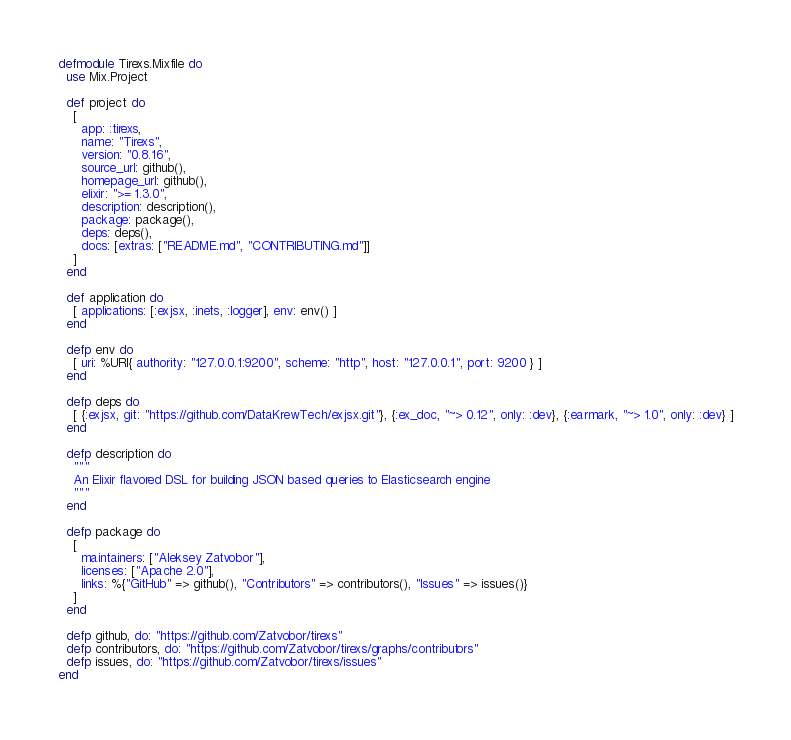Convert code to text. <code><loc_0><loc_0><loc_500><loc_500><_Elixir_>defmodule Tirexs.Mixfile do
  use Mix.Project

  def project do
    [
      app: :tirexs,
      name: "Tirexs",
      version: "0.8.16",
      source_url: github(),
      homepage_url: github(),
      elixir: ">= 1.3.0",
      description: description(),
      package: package(),
      deps: deps(),
      docs: [extras: ["README.md", "CONTRIBUTING.md"]]
    ]
  end

  def application do
    [ applications: [:exjsx, :inets, :logger], env: env() ]
  end

  defp env do
    [ uri: %URI{ authority: "127.0.0.1:9200", scheme: "http", host: "127.0.0.1", port: 9200 } ]
  end

  defp deps do
    [ {:exjsx, git: "https://github.com/DataKrewTech/exjsx.git"}, {:ex_doc, "~> 0.12", only: :dev}, {:earmark, "~> 1.0", only: :dev} ]
  end

  defp description do
    """
    An Elixir flavored DSL for building JSON based queries to Elasticsearch engine
    """
  end

  defp package do
    [
      maintainers: ["Aleksey Zatvobor"],
      licenses: ["Apache 2.0"],
      links: %{"GitHub" => github(), "Contributors" => contributors(), "Issues" => issues()}
    ]
  end

  defp github, do: "https://github.com/Zatvobor/tirexs"
  defp contributors, do: "https://github.com/Zatvobor/tirexs/graphs/contributors"
  defp issues, do: "https://github.com/Zatvobor/tirexs/issues"
end
</code> 